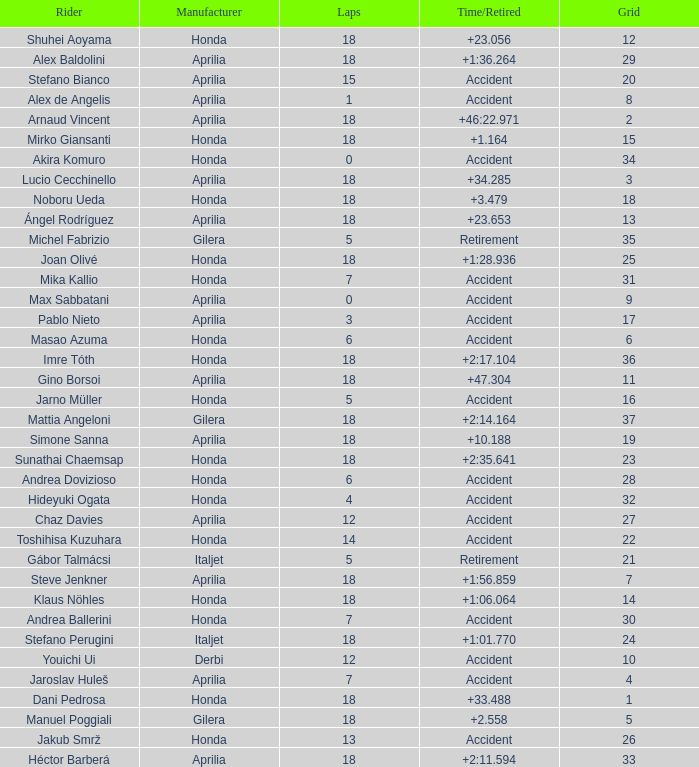What is the average number of laps with an accident time/retired, aprilia manufacturer and a grid of 27? 12.0. 